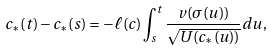Convert formula to latex. <formula><loc_0><loc_0><loc_500><loc_500>c _ { \ast } ( t ) - c _ { \ast } ( s ) = - \ell ( c ) \int _ { s } ^ { t } \frac { v ( \sigma ( u ) ) } { \sqrt { U ( c _ { \ast } ( u ) ) } } d u ,</formula> 